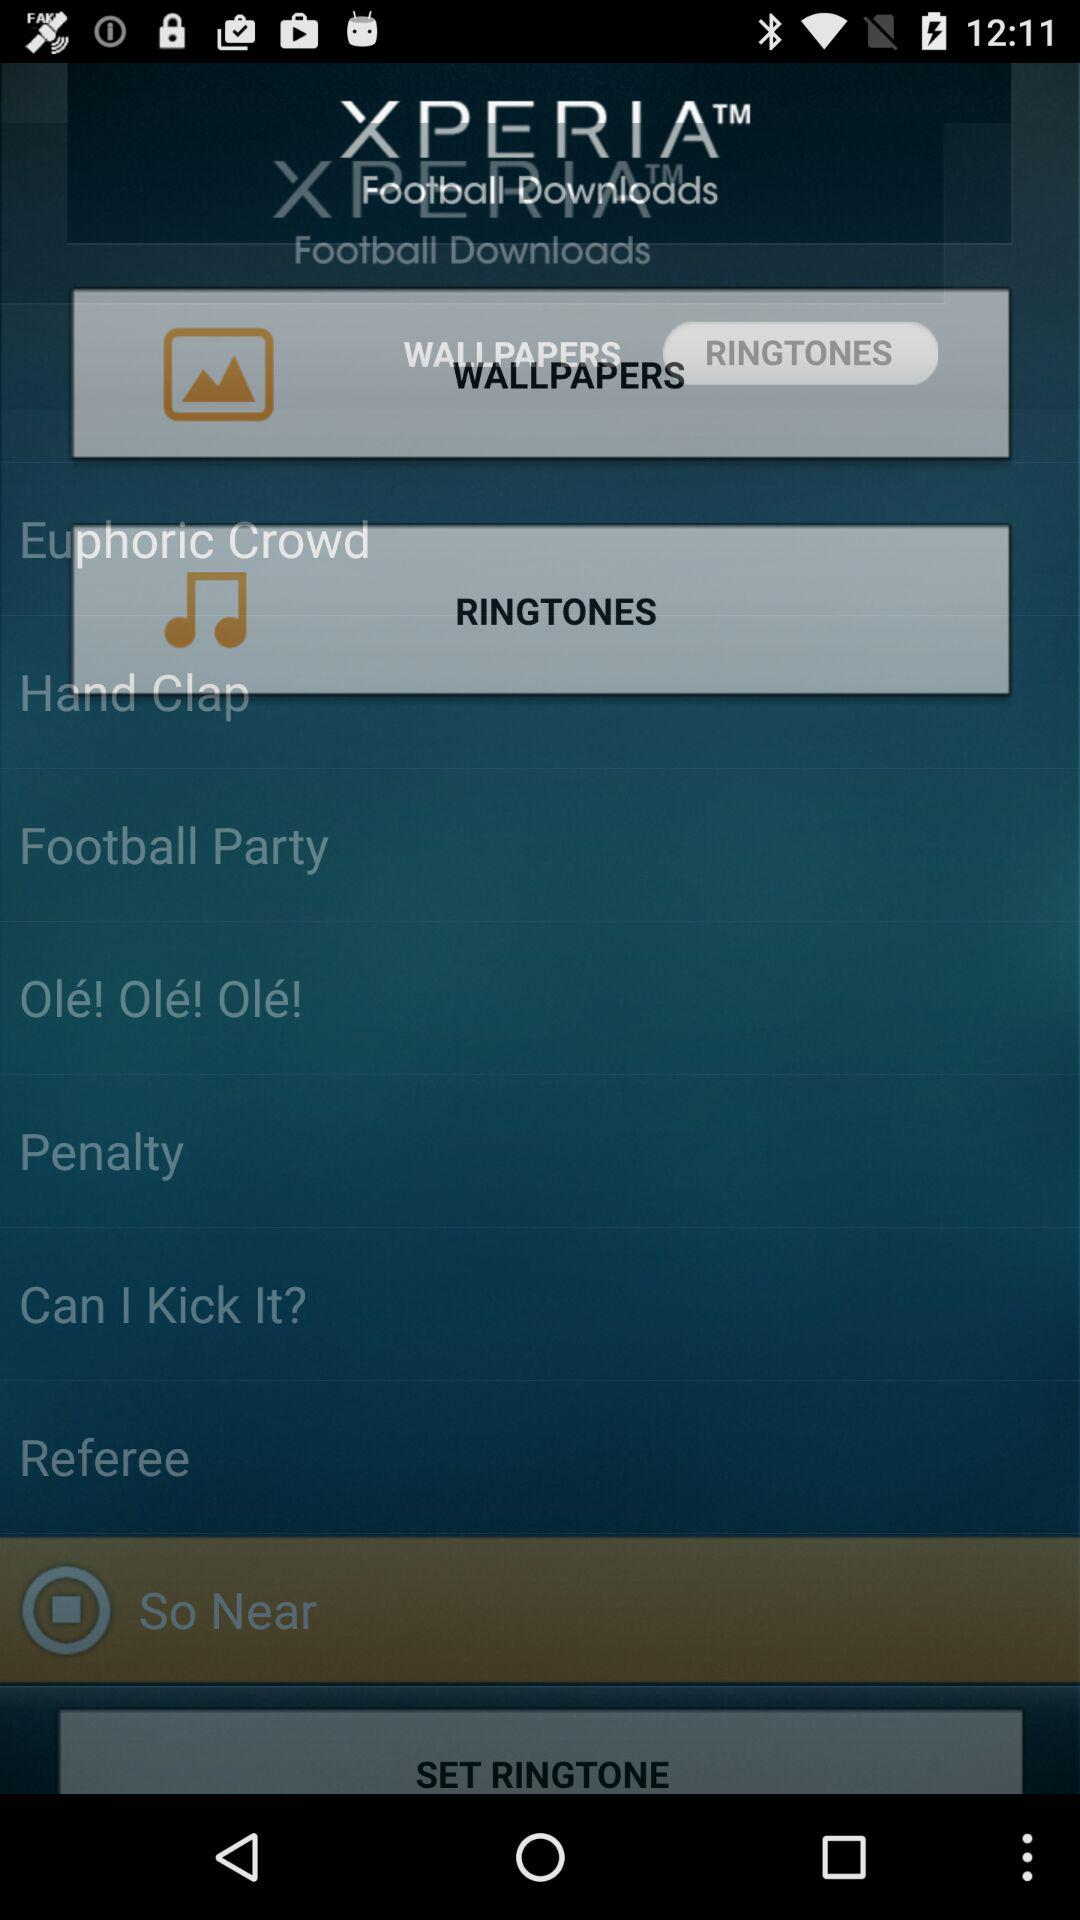What are the available wallpapers?
When the provided information is insufficient, respond with <no answer>. <no answer> 